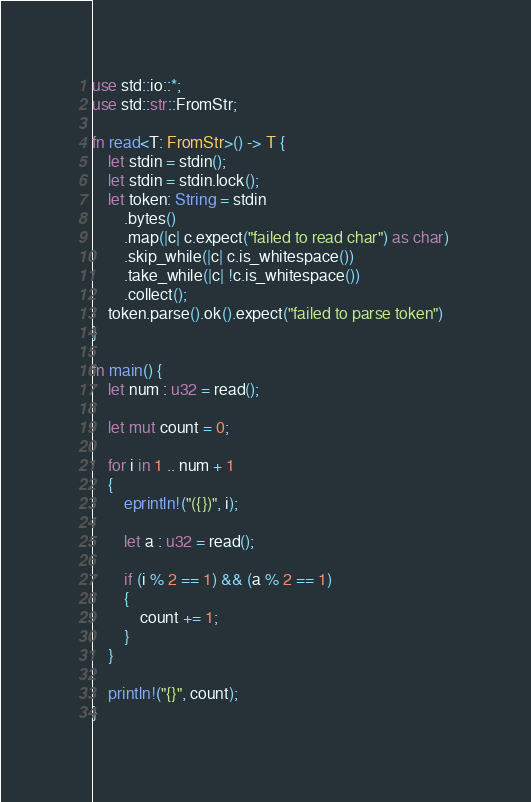<code> <loc_0><loc_0><loc_500><loc_500><_Rust_>use std::io::*;
use std::str::FromStr;

fn read<T: FromStr>() -> T {
    let stdin = stdin();
    let stdin = stdin.lock();
    let token: String = stdin
        .bytes()
        .map(|c| c.expect("failed to read char") as char) 
        .skip_while(|c| c.is_whitespace())
        .take_while(|c| !c.is_whitespace())
        .collect();
    token.parse().ok().expect("failed to parse token")
}

fn main() {
    let num : u32 = read();

    let mut count = 0;

    for i in 1 .. num + 1
    {
        eprintln!("({})", i);

        let a : u32 = read();

        if (i % 2 == 1) && (a % 2 == 1)
        {
            count += 1;
        }
    }

    println!("{}", count);
}
</code> 